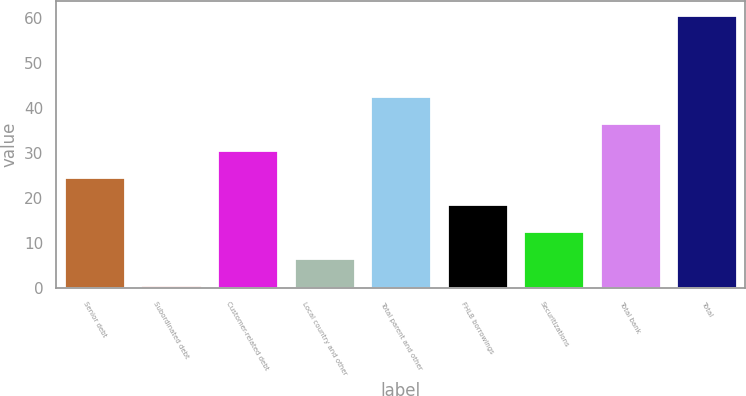Convert chart to OTSL. <chart><loc_0><loc_0><loc_500><loc_500><bar_chart><fcel>Senior debt<fcel>Subordinated debt<fcel>Customer-related debt<fcel>Local country and other<fcel>Total parent and other<fcel>FHLB borrowings<fcel>Securitizations<fcel>Total bank<fcel>Total<nl><fcel>24.64<fcel>0.6<fcel>30.65<fcel>6.61<fcel>42.67<fcel>18.63<fcel>12.62<fcel>36.66<fcel>60.7<nl></chart> 